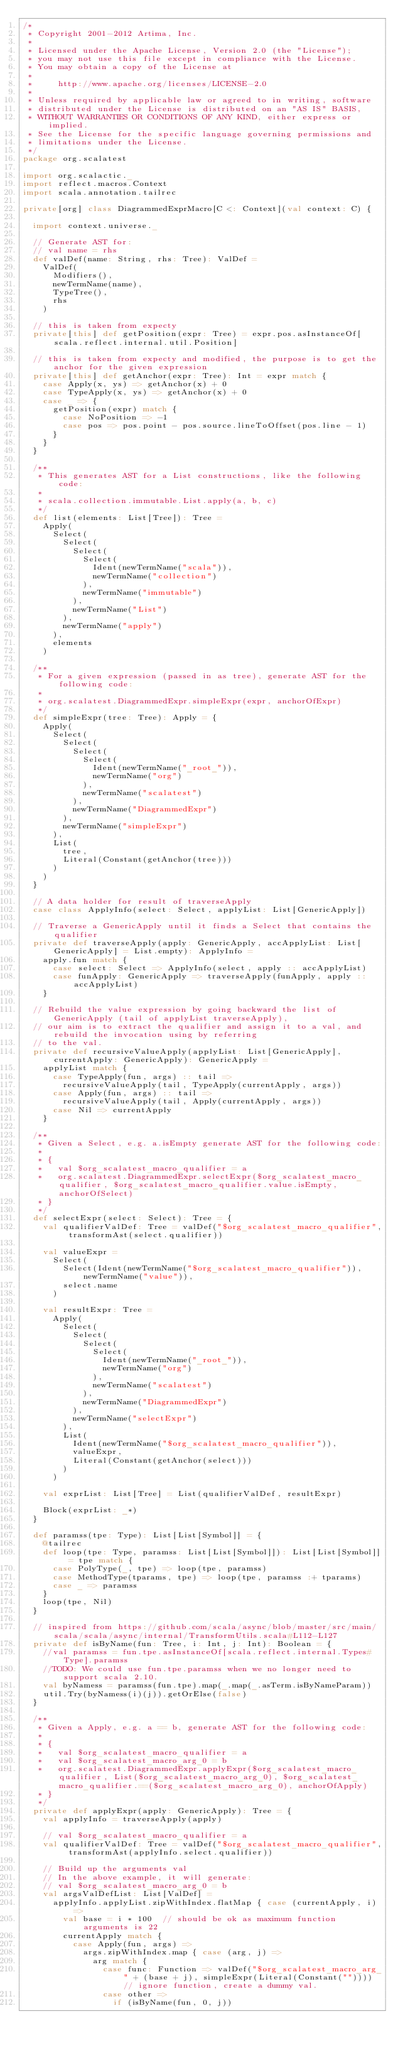Convert code to text. <code><loc_0><loc_0><loc_500><loc_500><_Scala_>/*
 * Copyright 2001-2012 Artima, Inc.
 *
 * Licensed under the Apache License, Version 2.0 (the "License");
 * you may not use this file except in compliance with the License.
 * You may obtain a copy of the License at
 *
 *     http://www.apache.org/licenses/LICENSE-2.0
 *
 * Unless required by applicable law or agreed to in writing, software
 * distributed under the License is distributed on an "AS IS" BASIS,
 * WITHOUT WARRANTIES OR CONDITIONS OF ANY KIND, either express or implied.
 * See the License for the specific language governing permissions and
 * limitations under the License.
 */
package org.scalatest

import org.scalactic._
import reflect.macros.Context
import scala.annotation.tailrec

private[org] class DiagrammedExprMacro[C <: Context](val context: C) {

  import context.universe._

  // Generate AST for:
  // val name = rhs
  def valDef(name: String, rhs: Tree): ValDef =
    ValDef(
      Modifiers(),
      newTermName(name),
      TypeTree(),
      rhs
    )

  // this is taken from expecty
  private[this] def getPosition(expr: Tree) = expr.pos.asInstanceOf[scala.reflect.internal.util.Position]

  // this is taken from expecty and modified, the purpose is to get the anchor for the given expression
  private[this] def getAnchor(expr: Tree): Int = expr match {
    case Apply(x, ys) => getAnchor(x) + 0
    case TypeApply(x, ys) => getAnchor(x) + 0
    case _ => {
      getPosition(expr) match {
        case NoPosition => -1
        case pos => pos.point - pos.source.lineToOffset(pos.line - 1)
      }
    }
  }

  /**
   * This generates AST for a List constructions, like the following code:
   *
   * scala.collection.immutable.List.apply(a, b, c)
   */
  def list(elements: List[Tree]): Tree =
    Apply(
      Select(
        Select(
          Select(
            Select(
              Ident(newTermName("scala")),
              newTermName("collection")
            ),
            newTermName("immutable")
          ),
          newTermName("List")
        ),
        newTermName("apply")
      ),
      elements
    )

  /**
   * For a given expression (passed in as tree), generate AST for the following code:
   *
   * org.scalatest.DiagrammedExpr.simpleExpr(expr, anchorOfExpr)
   */
  def simpleExpr(tree: Tree): Apply = {
    Apply(
      Select(
        Select(
          Select(
            Select(
              Ident(newTermName("_root_")),
              newTermName("org")
            ),
            newTermName("scalatest")
          ),
          newTermName("DiagrammedExpr")
        ),
        newTermName("simpleExpr")
      ),
      List(
        tree,
        Literal(Constant(getAnchor(tree)))
      )
    )
  }

  // A data holder for result of traverseApply
  case class ApplyInfo(select: Select, applyList: List[GenericApply])

  // Traverse a GenericApply until it finds a Select that contains the qualifier
  private def traverseApply(apply: GenericApply, accApplyList: List[GenericApply] = List.empty): ApplyInfo =
    apply.fun match {
      case select: Select => ApplyInfo(select, apply :: accApplyList)
      case funApply: GenericApply => traverseApply(funApply, apply :: accApplyList)
    }

  // Rebuild the value expression by going backward the list of GenericApply (tail of applyList traverseApply),
  // our aim is to extract the qualifier and assign it to a val, and rebuild the invocation using by referring
  // to the val.
  private def recursiveValueApply(applyList: List[GenericApply], currentApply: GenericApply): GenericApply =
    applyList match {
      case TypeApply(fun, args) :: tail =>
        recursiveValueApply(tail, TypeApply(currentApply, args))
      case Apply(fun, args) :: tail =>
        recursiveValueApply(tail, Apply(currentApply, args))
      case Nil => currentApply
    }

  /**
   * Given a Select, e.g. a.isEmpty generate AST for the following code:
   *
   * {
   *   val $org_scalatest_macro_qualifier = a
   *   org.scalatest.DiagrammedExpr.selectExpr($org_scalatest_macro_qualifier, $org_scalatest_macro_qualifier.value.isEmpty, anchorOfSelect)
   * }
   */
  def selectExpr(select: Select): Tree = {
    val qualifierValDef: Tree = valDef("$org_scalatest_macro_qualifier", transformAst(select.qualifier))

    val valueExpr =
      Select(
        Select(Ident(newTermName("$org_scalatest_macro_qualifier")), newTermName("value")),
        select.name
      )

    val resultExpr: Tree =
      Apply(
        Select(
          Select(
            Select(
              Select(
                Ident(newTermName("_root_")),
                newTermName("org")
              ),
              newTermName("scalatest")
            ),
            newTermName("DiagrammedExpr")
          ),
          newTermName("selectExpr")
        ),
        List(
          Ident(newTermName("$org_scalatest_macro_qualifier")),
          valueExpr,
          Literal(Constant(getAnchor(select)))
        )
      )

    val exprList: List[Tree] = List(qualifierValDef, resultExpr)

    Block(exprList: _*)
  }

  def paramss(tpe: Type): List[List[Symbol]] = {
    @tailrec
    def loop(tpe: Type, paramss: List[List[Symbol]]): List[List[Symbol]] = tpe match {
      case PolyType(_, tpe) => loop(tpe, paramss)
      case MethodType(tparams, tpe) => loop(tpe, paramss :+ tparams)
      case _ => paramss
    }
    loop(tpe, Nil)
  }

  // inspired from https://github.com/scala/async/blob/master/src/main/scala/scala/async/internal/TransformUtils.scala#L112-L127
  private def isByName(fun: Tree, i: Int, j: Int): Boolean = {
    //val paramss = fun.tpe.asInstanceOf[scala.reflect.internal.Types#Type].paramss
    //TODO: We could use fun.tpe.paramss when we no longer need to support scala 2.10.
    val byNamess = paramss(fun.tpe).map(_.map(_.asTerm.isByNameParam))
    util.Try(byNamess(i)(j)).getOrElse(false)
  }

  /**
   * Given a Apply, e.g. a == b, generate AST for the following code:
   *
   * {
   *   val $org_scalatest_macro_qualifier = a
   *   val $org_scalatest_macro_arg_0 = b
   *   org.scalatest.DiagrammedExpr.applyExpr($org_scalatest_macro_qualifier, List($org_scalatest_macro_arg_0), $org_scalatest_macro_qualifier.==($org_scalatest_macro_arg_0), anchorOfApply)
   * }
   */
  private def applyExpr(apply: GenericApply): Tree = {
    val applyInfo = traverseApply(apply)

    // val $org_scalatest_macro_qualifier = a
    val qualifierValDef: Tree = valDef("$org_scalatest_macro_qualifier", transformAst(applyInfo.select.qualifier))

    // Build up the arguments val
    // In the above example, it will generate:
    // val $org_scalatest_macro_arg_0 = b
    val argsValDefList: List[ValDef] =
      applyInfo.applyList.zipWithIndex.flatMap { case (currentApply, i) =>
        val base = i * 100  // should be ok as maximum function arguments is 22
        currentApply match {
          case Apply(fun, args) =>
            args.zipWithIndex.map { case (arg, j) =>
              arg match {
                case func: Function => valDef("$org_scalatest_macro_arg_" + (base + j), simpleExpr(Literal(Constant("")))) // ignore function, create a dummy val.
                case other =>
                  if (isByName(fun, 0, j))</code> 